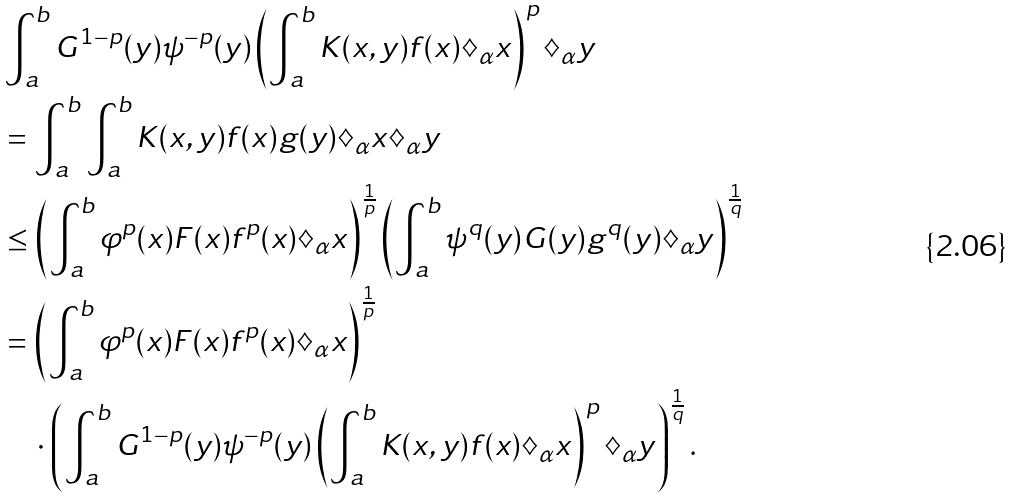Convert formula to latex. <formula><loc_0><loc_0><loc_500><loc_500>& \int _ { a } ^ { b } G ^ { 1 - p } ( y ) \psi ^ { - p } ( y ) \left ( \int _ { a } ^ { b } K ( x , y ) f ( x ) \diamondsuit _ { \alpha } x \right ) ^ { p } \diamondsuit _ { \alpha } y \\ & = \int _ { a } ^ { b } \int _ { a } ^ { b } K ( x , y ) f ( x ) g ( y ) \diamondsuit _ { \alpha } x \diamondsuit _ { \alpha } y \\ & \leq \left ( \int _ { a } ^ { b } \varphi ^ { p } ( x ) F ( x ) f ^ { p } ( x ) \diamondsuit _ { \alpha } x \right ) ^ { \frac { 1 } { p } } \left ( \int _ { a } ^ { b } \psi ^ { q } ( y ) G ( y ) g ^ { q } ( y ) \diamondsuit _ { \alpha } y \right ) ^ { \frac { 1 } { q } } \\ & = \left ( \int _ { a } ^ { b } \varphi ^ { p } ( x ) F ( x ) f ^ { p } ( x ) \diamondsuit _ { \alpha } x \right ) ^ { \frac { 1 } { p } } \\ & \quad \cdot \left ( \int _ { a } ^ { b } G ^ { 1 - p } ( y ) \psi ^ { - p } ( y ) \left ( \int _ { a } ^ { b } K ( x , y ) f ( x ) \diamondsuit _ { \alpha } x \right ) ^ { p } \diamondsuit _ { \alpha } y \right ) ^ { \frac { 1 } { q } } .</formula> 